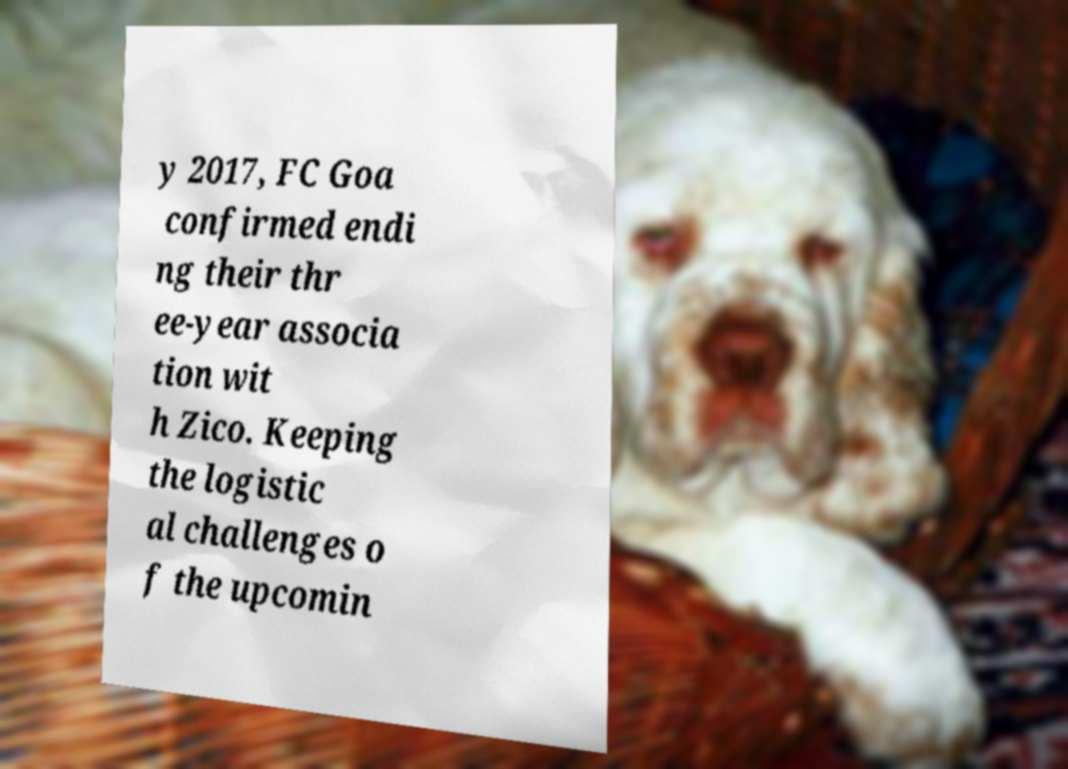Can you accurately transcribe the text from the provided image for me? y 2017, FC Goa confirmed endi ng their thr ee-year associa tion wit h Zico. Keeping the logistic al challenges o f the upcomin 